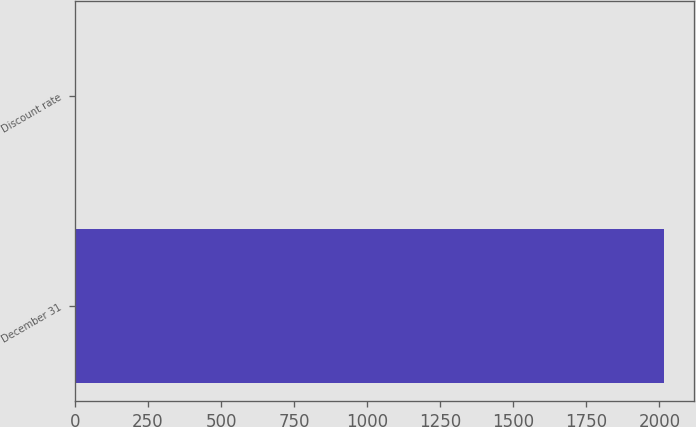Convert chart. <chart><loc_0><loc_0><loc_500><loc_500><bar_chart><fcel>December 31<fcel>Discount rate<nl><fcel>2017<fcel>3.5<nl></chart> 